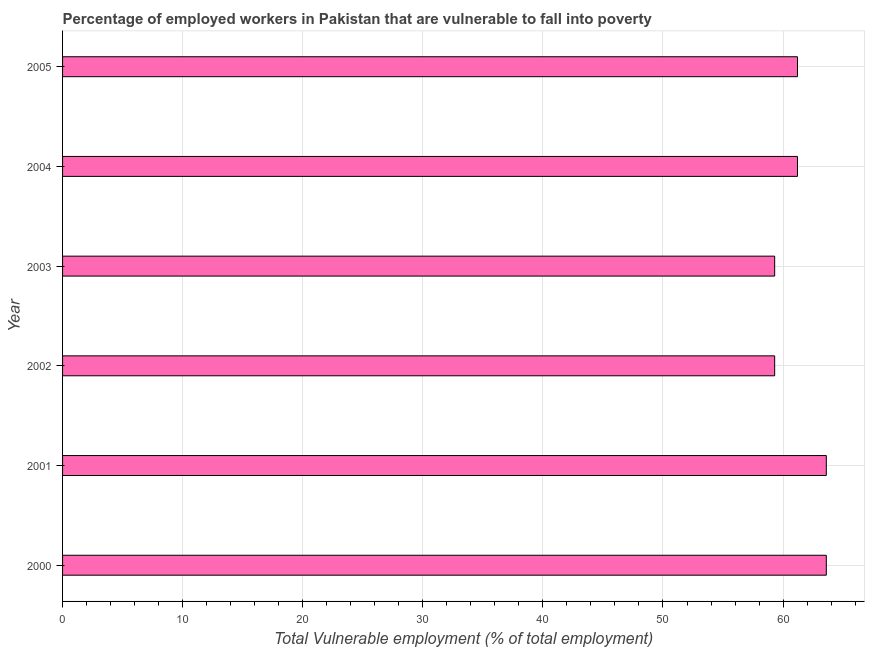Does the graph contain any zero values?
Ensure brevity in your answer.  No. What is the title of the graph?
Keep it short and to the point. Percentage of employed workers in Pakistan that are vulnerable to fall into poverty. What is the label or title of the X-axis?
Provide a succinct answer. Total Vulnerable employment (% of total employment). What is the total vulnerable employment in 2002?
Offer a very short reply. 59.3. Across all years, what is the maximum total vulnerable employment?
Keep it short and to the point. 63.6. Across all years, what is the minimum total vulnerable employment?
Your answer should be compact. 59.3. In which year was the total vulnerable employment minimum?
Keep it short and to the point. 2002. What is the sum of the total vulnerable employment?
Your response must be concise. 368.2. What is the average total vulnerable employment per year?
Your answer should be very brief. 61.37. What is the median total vulnerable employment?
Make the answer very short. 61.2. In how many years, is the total vulnerable employment greater than 18 %?
Offer a terse response. 6. Do a majority of the years between 2002 and 2005 (inclusive) have total vulnerable employment greater than 46 %?
Provide a succinct answer. Yes. Is the total vulnerable employment in 2002 less than that in 2003?
Ensure brevity in your answer.  No. What is the difference between the highest and the second highest total vulnerable employment?
Your answer should be compact. 0. What is the difference between the highest and the lowest total vulnerable employment?
Offer a terse response. 4.3. In how many years, is the total vulnerable employment greater than the average total vulnerable employment taken over all years?
Provide a succinct answer. 2. Are all the bars in the graph horizontal?
Keep it short and to the point. Yes. What is the Total Vulnerable employment (% of total employment) in 2000?
Give a very brief answer. 63.6. What is the Total Vulnerable employment (% of total employment) in 2001?
Make the answer very short. 63.6. What is the Total Vulnerable employment (% of total employment) of 2002?
Your answer should be very brief. 59.3. What is the Total Vulnerable employment (% of total employment) of 2003?
Ensure brevity in your answer.  59.3. What is the Total Vulnerable employment (% of total employment) in 2004?
Your answer should be compact. 61.2. What is the Total Vulnerable employment (% of total employment) in 2005?
Provide a short and direct response. 61.2. What is the difference between the Total Vulnerable employment (% of total employment) in 2000 and 2001?
Your answer should be compact. 0. What is the difference between the Total Vulnerable employment (% of total employment) in 2000 and 2002?
Your answer should be compact. 4.3. What is the difference between the Total Vulnerable employment (% of total employment) in 2002 and 2005?
Offer a terse response. -1.9. What is the difference between the Total Vulnerable employment (% of total employment) in 2003 and 2005?
Offer a terse response. -1.9. What is the ratio of the Total Vulnerable employment (% of total employment) in 2000 to that in 2001?
Offer a terse response. 1. What is the ratio of the Total Vulnerable employment (% of total employment) in 2000 to that in 2002?
Give a very brief answer. 1.07. What is the ratio of the Total Vulnerable employment (% of total employment) in 2000 to that in 2003?
Your answer should be very brief. 1.07. What is the ratio of the Total Vulnerable employment (% of total employment) in 2000 to that in 2004?
Your response must be concise. 1.04. What is the ratio of the Total Vulnerable employment (% of total employment) in 2000 to that in 2005?
Your answer should be very brief. 1.04. What is the ratio of the Total Vulnerable employment (% of total employment) in 2001 to that in 2002?
Your answer should be compact. 1.07. What is the ratio of the Total Vulnerable employment (% of total employment) in 2001 to that in 2003?
Make the answer very short. 1.07. What is the ratio of the Total Vulnerable employment (% of total employment) in 2001 to that in 2004?
Provide a succinct answer. 1.04. What is the ratio of the Total Vulnerable employment (% of total employment) in 2001 to that in 2005?
Ensure brevity in your answer.  1.04. What is the ratio of the Total Vulnerable employment (% of total employment) in 2002 to that in 2003?
Give a very brief answer. 1. What is the ratio of the Total Vulnerable employment (% of total employment) in 2002 to that in 2004?
Provide a short and direct response. 0.97. What is the ratio of the Total Vulnerable employment (% of total employment) in 2002 to that in 2005?
Ensure brevity in your answer.  0.97. What is the ratio of the Total Vulnerable employment (% of total employment) in 2003 to that in 2004?
Offer a terse response. 0.97. 